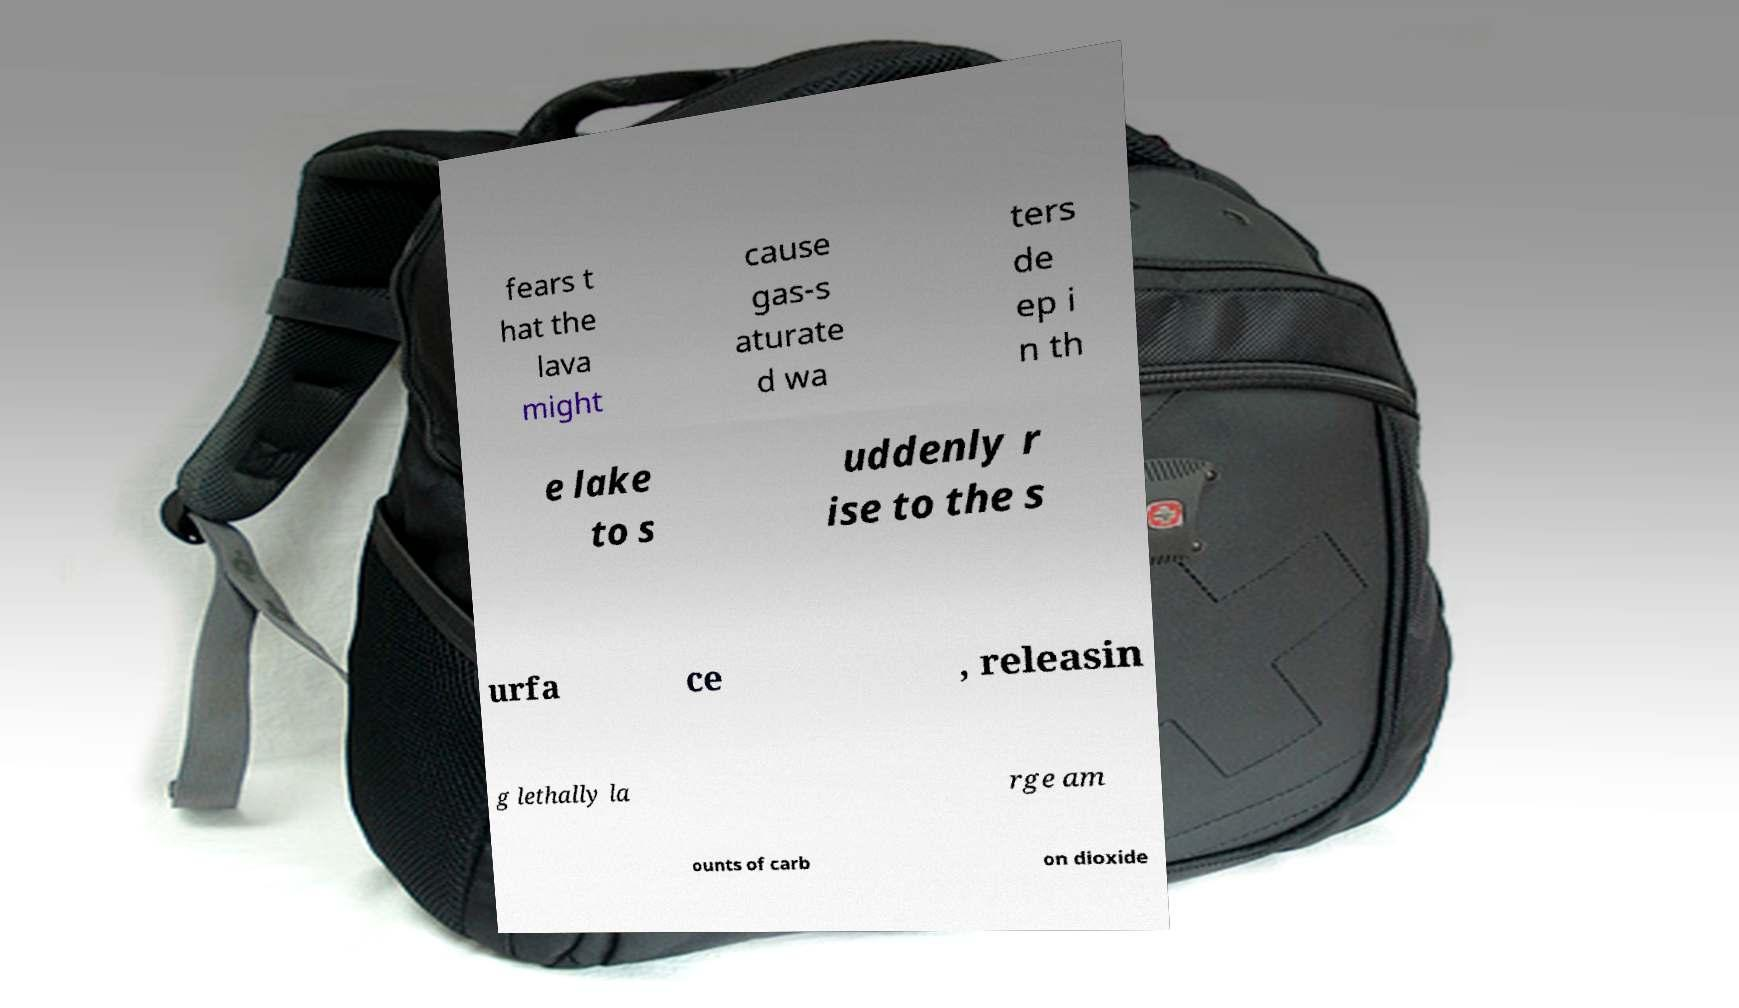For documentation purposes, I need the text within this image transcribed. Could you provide that? fears t hat the lava might cause gas-s aturate d wa ters de ep i n th e lake to s uddenly r ise to the s urfa ce , releasin g lethally la rge am ounts of carb on dioxide 